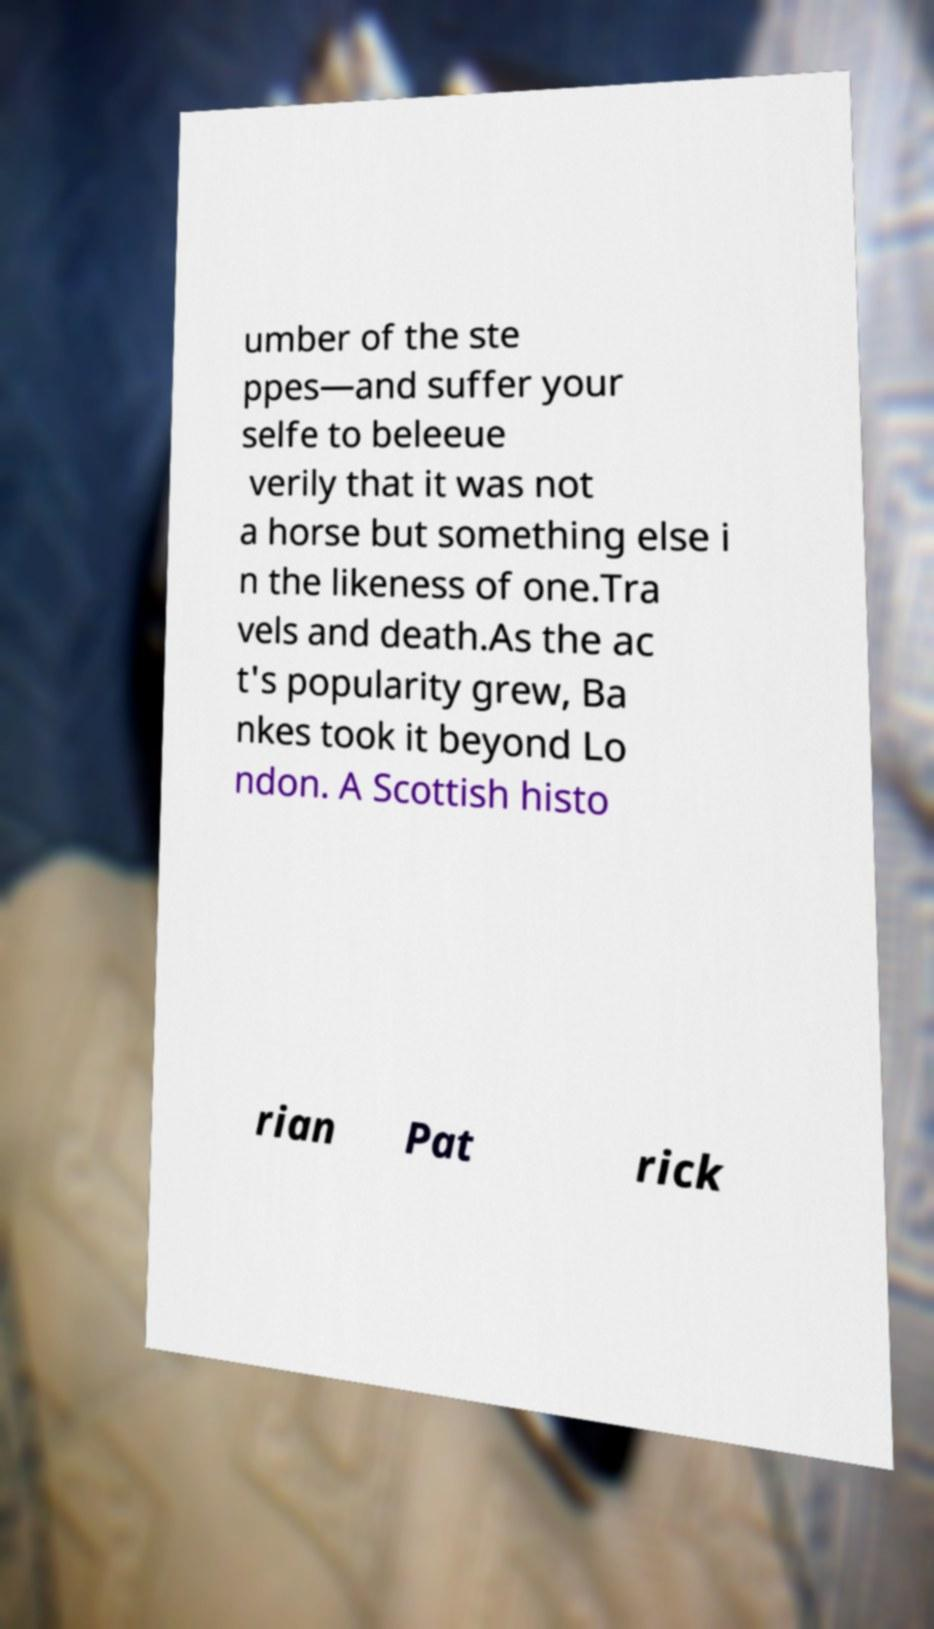Could you extract and type out the text from this image? umber of the ste ppes—and suffer your selfe to beleeue verily that it was not a horse but something else i n the likeness of one.Tra vels and death.As the ac t's popularity grew, Ba nkes took it beyond Lo ndon. A Scottish histo rian Pat rick 